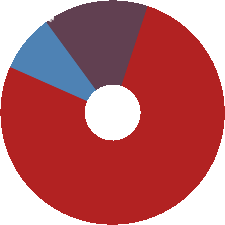Convert chart to OTSL. <chart><loc_0><loc_0><loc_500><loc_500><pie_chart><fcel>Cost of product revenue<fcel>Research and development<fcel>Selling general and<nl><fcel>8.3%<fcel>15.13%<fcel>76.57%<nl></chart> 